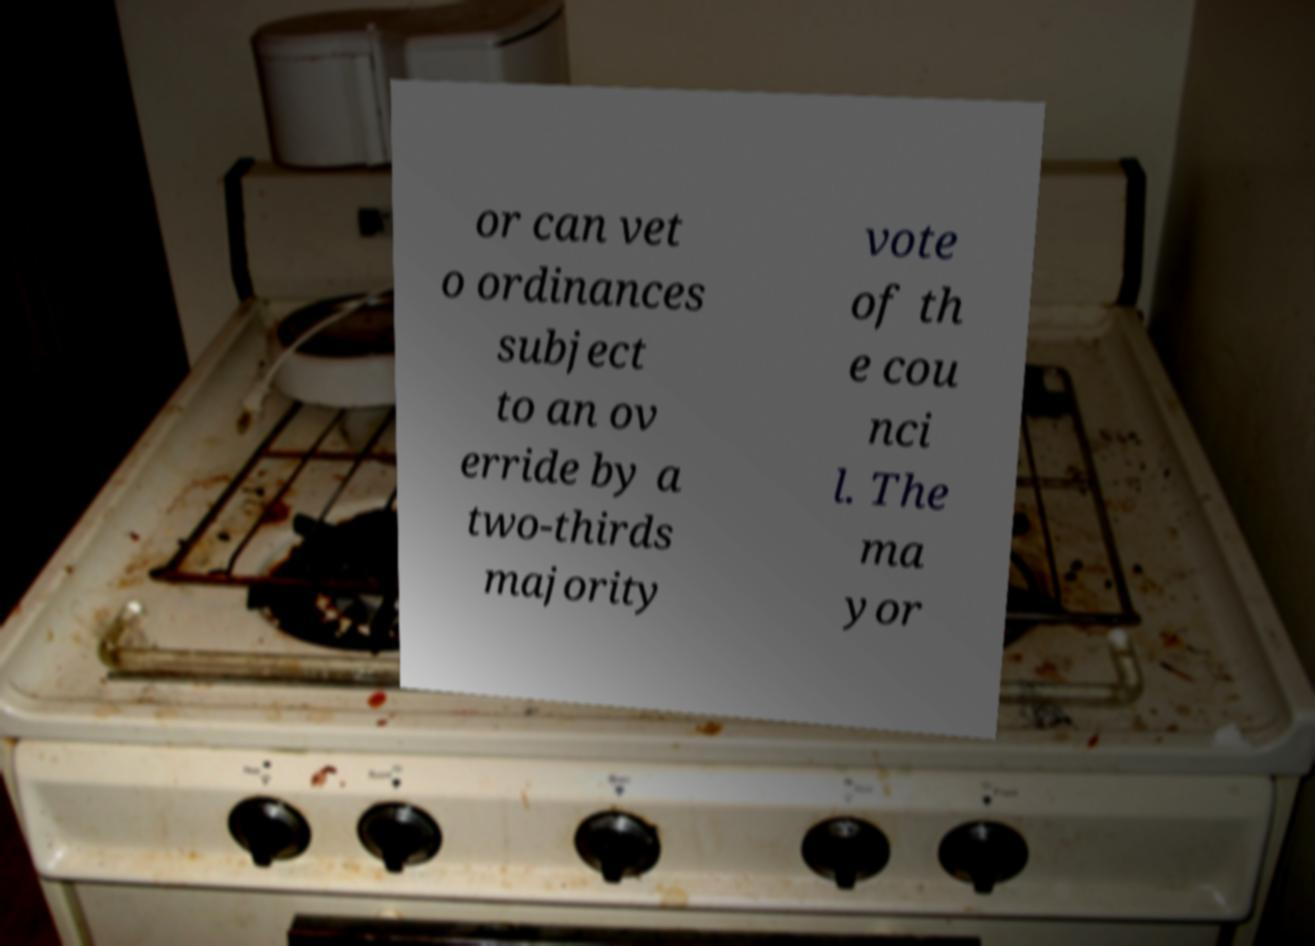Could you extract and type out the text from this image? or can vet o ordinances subject to an ov erride by a two-thirds majority vote of th e cou nci l. The ma yor 